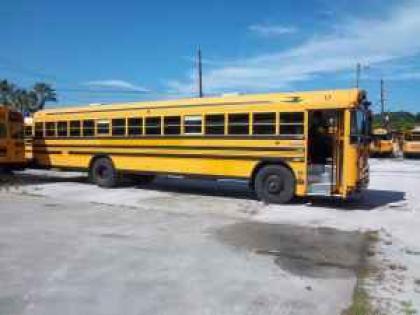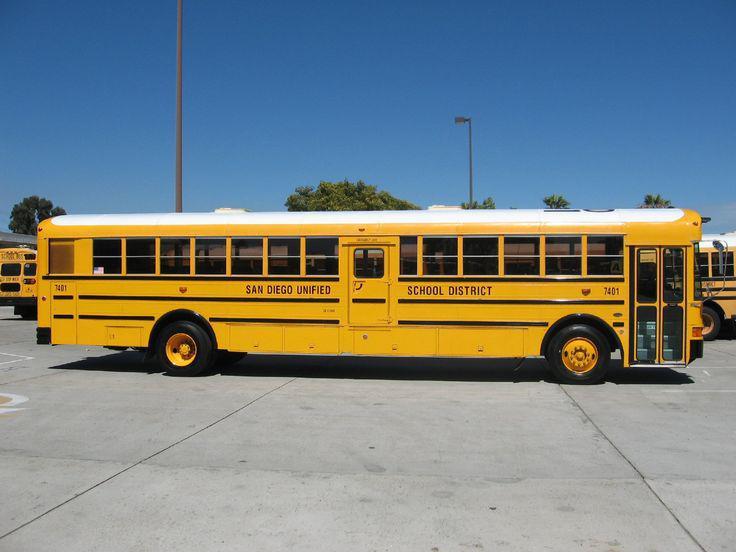The first image is the image on the left, the second image is the image on the right. Assess this claim about the two images: "Left and right images each contain one new-condition yellow bus with a sloped front instead of a flat front and no more than five passenger windows per side.". Correct or not? Answer yes or no. No. The first image is the image on the left, the second image is the image on the right. Analyze the images presented: Is the assertion "Both buses are pointing to the right." valid? Answer yes or no. Yes. 